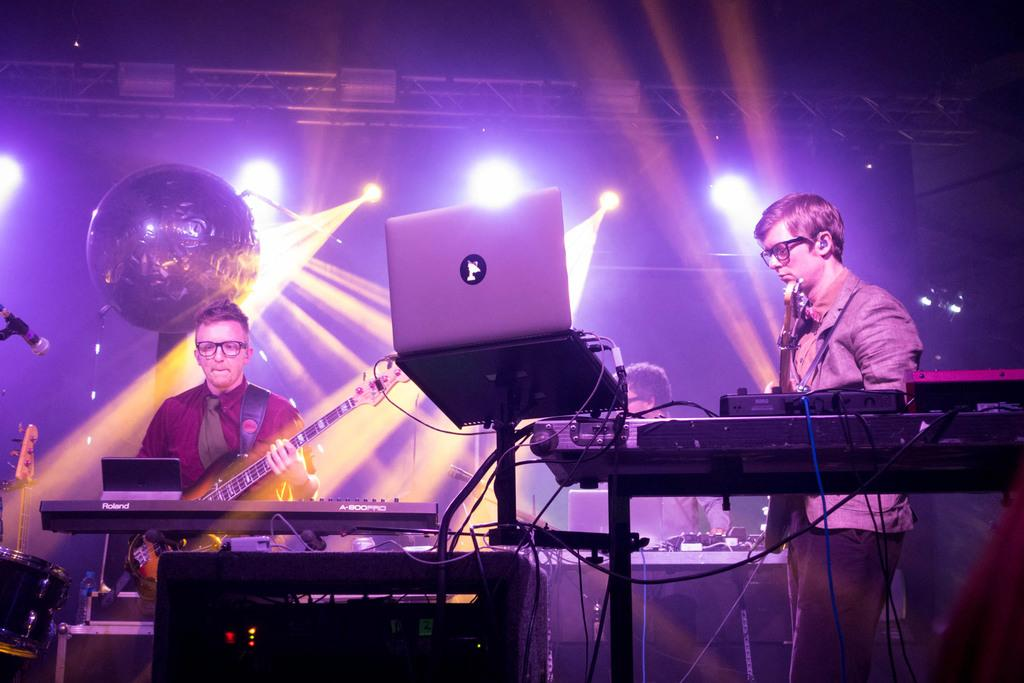How many people are in the image? There are people in the image, but the exact number is not specified. What are the people doing in the image? The people are standing and playing musical instruments. Can you describe the actions of the people in the image? The people are standing and playing musical instruments, which suggests they might be performing or practicing music. What type of card game are the people playing in the image? There is no card game present in the image; the people are standing and playing musical instruments. Can you tell me how many people are swimming in the image? There is no swimming activity depicted in the image; the people are standing and playing musical instruments. 